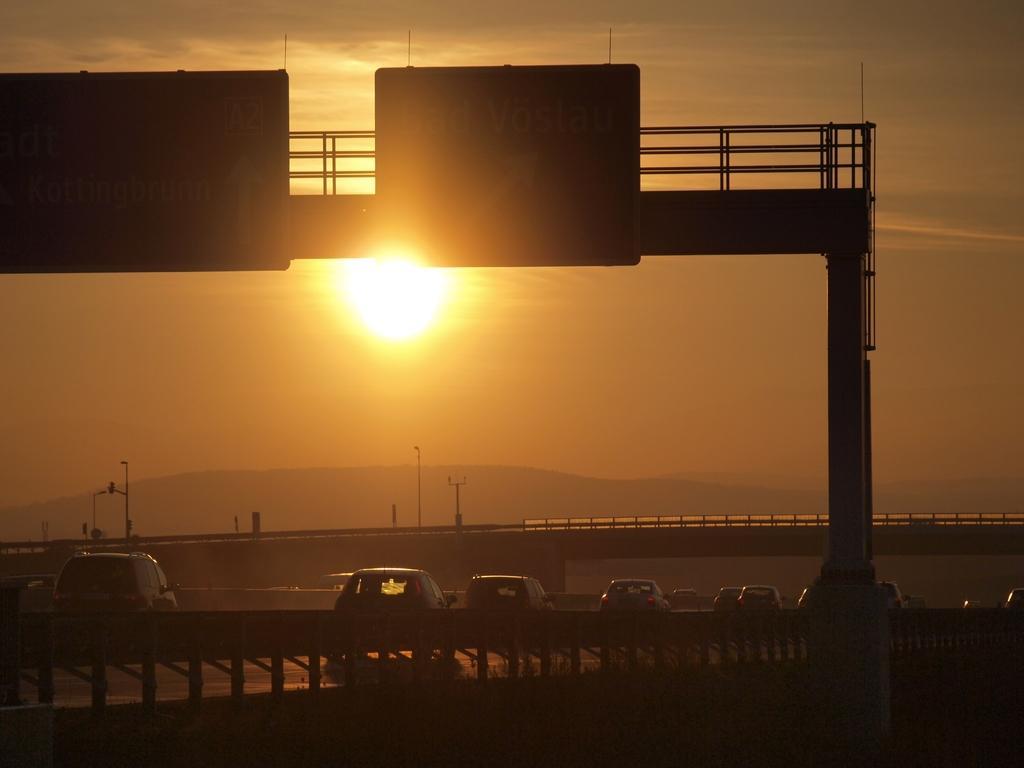How would you summarize this image in a sentence or two? Vehicles are on the road. In this image we can see signboards, bridges, poles and mountain. Sun in the sky 